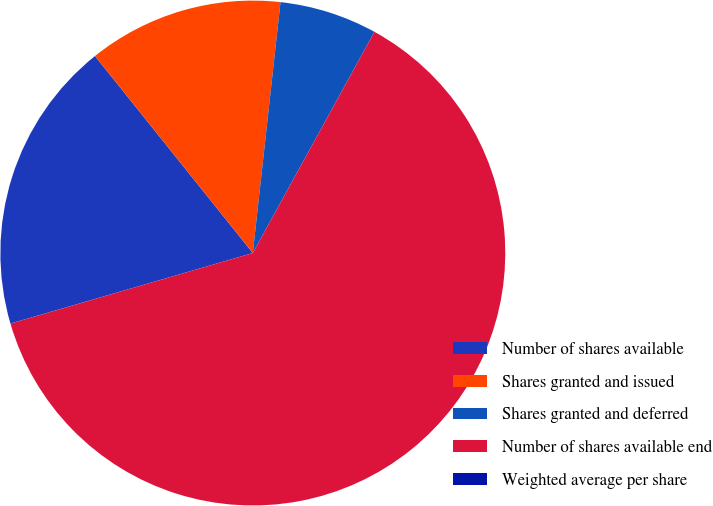Convert chart. <chart><loc_0><loc_0><loc_500><loc_500><pie_chart><fcel>Number of shares available<fcel>Shares granted and issued<fcel>Shares granted and deferred<fcel>Number of shares available end<fcel>Weighted average per share<nl><fcel>18.75%<fcel>12.5%<fcel>6.25%<fcel>62.48%<fcel>0.01%<nl></chart> 